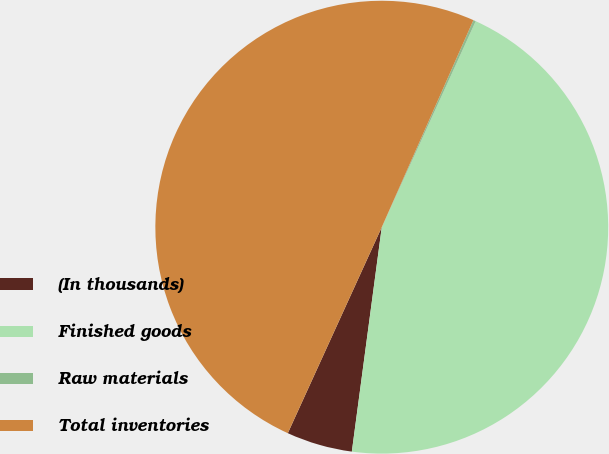Convert chart to OTSL. <chart><loc_0><loc_0><loc_500><loc_500><pie_chart><fcel>(In thousands)<fcel>Finished goods<fcel>Raw materials<fcel>Total inventories<nl><fcel>4.7%<fcel>45.3%<fcel>0.18%<fcel>49.82%<nl></chart> 